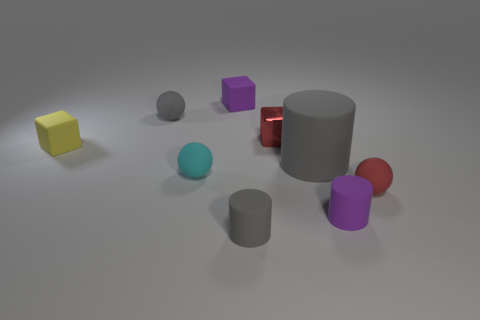There is a red metallic object; does it have the same size as the purple thing to the left of the red metal block?
Give a very brief answer. Yes. Is the number of purple things that are behind the big gray matte thing less than the number of small red matte things?
Make the answer very short. No. There is a gray thing that is the same shape as the red rubber object; what is it made of?
Provide a short and direct response. Rubber. What shape is the small rubber object that is on the right side of the small cyan matte ball and behind the big gray thing?
Keep it short and to the point. Cube. There is a small yellow thing that is the same material as the tiny cyan sphere; what shape is it?
Give a very brief answer. Cube. There is a tiny gray object behind the big rubber cylinder; what is it made of?
Your response must be concise. Rubber. There is a shiny thing behind the small purple cylinder; does it have the same size as the purple object that is behind the large gray matte cylinder?
Your response must be concise. Yes. The large matte cylinder is what color?
Make the answer very short. Gray. Does the tiny purple matte object in front of the tiny red rubber thing have the same shape as the large gray thing?
Make the answer very short. Yes. What is the big cylinder made of?
Keep it short and to the point. Rubber. 